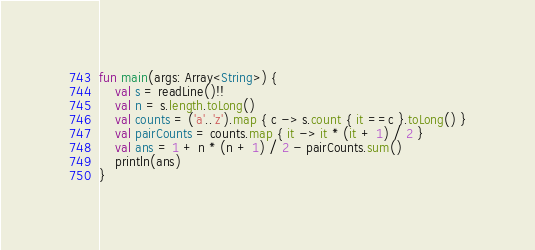Convert code to text. <code><loc_0><loc_0><loc_500><loc_500><_Kotlin_>fun main(args: Array<String>) {
    val s = readLine()!!
    val n = s.length.toLong()
    val counts = ('a'..'z').map { c -> s.count { it ==c }.toLong() }
    val pairCounts = counts.map { it -> it * (it + 1) / 2 }
    val ans = 1 + n * (n + 1) / 2 - pairCounts.sum()
    println(ans)
}</code> 